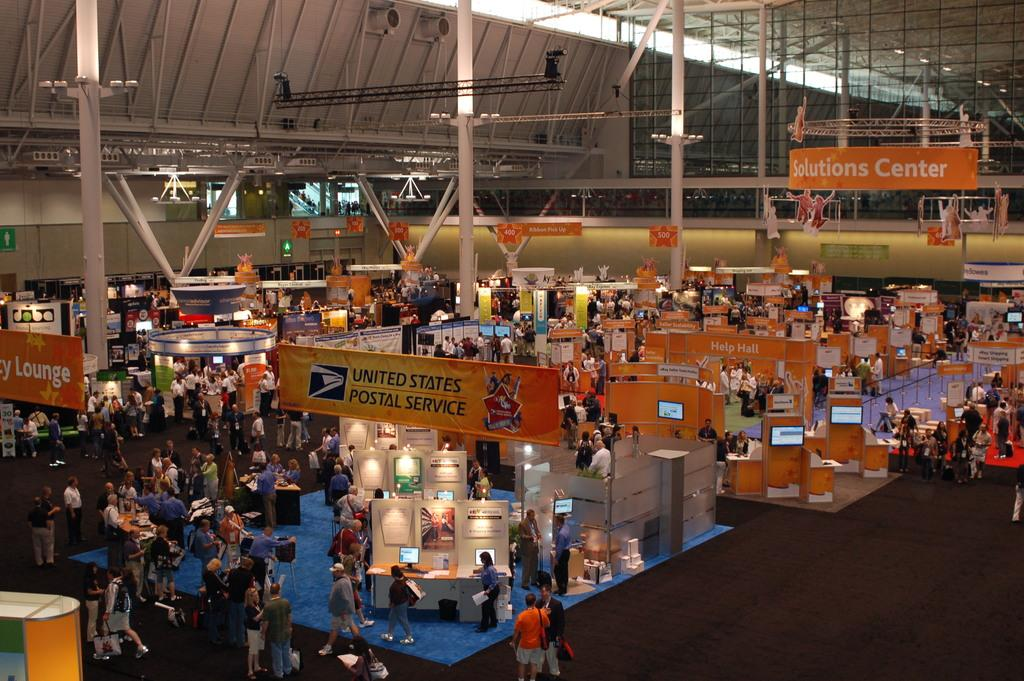What can be seen in the image involving people? There are persons standing in the image. What else is present in the image besides the people? There are banners in the image. What is the color of the banners? The banners are orange in color. How many rabbits can be seen interacting with the persons in the image? There are no rabbits present in the image; only persons and banners are visible. What is the primary use of the orange banners in the image? The primary use of the orange banners cannot be determined from the image alone, as their purpose is not evident. 